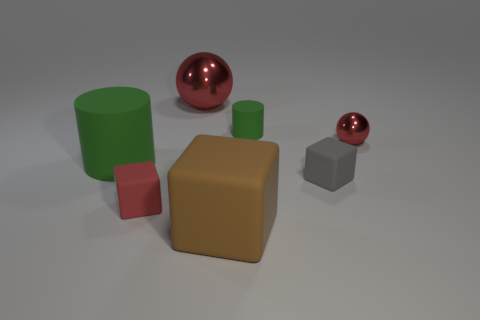How many cylinders are either red shiny objects or blue rubber things?
Your answer should be compact. 0. What material is the tiny ball that is the same color as the large metal ball?
Your answer should be compact. Metal. Do the tiny metallic thing and the large object behind the big cylinder have the same color?
Give a very brief answer. Yes. The big shiny object has what color?
Give a very brief answer. Red. How many objects are small red matte things or large green rubber things?
Offer a very short reply. 2. There is a green object that is the same size as the brown object; what material is it?
Make the answer very short. Rubber. There is a green matte thing to the left of the big metal ball; what size is it?
Provide a succinct answer. Large. What is the material of the small red ball?
Give a very brief answer. Metal. How many objects are either things in front of the large red metallic sphere or red metal balls on the left side of the gray block?
Make the answer very short. 7. What number of other things are there of the same color as the large cylinder?
Your answer should be very brief. 1. 